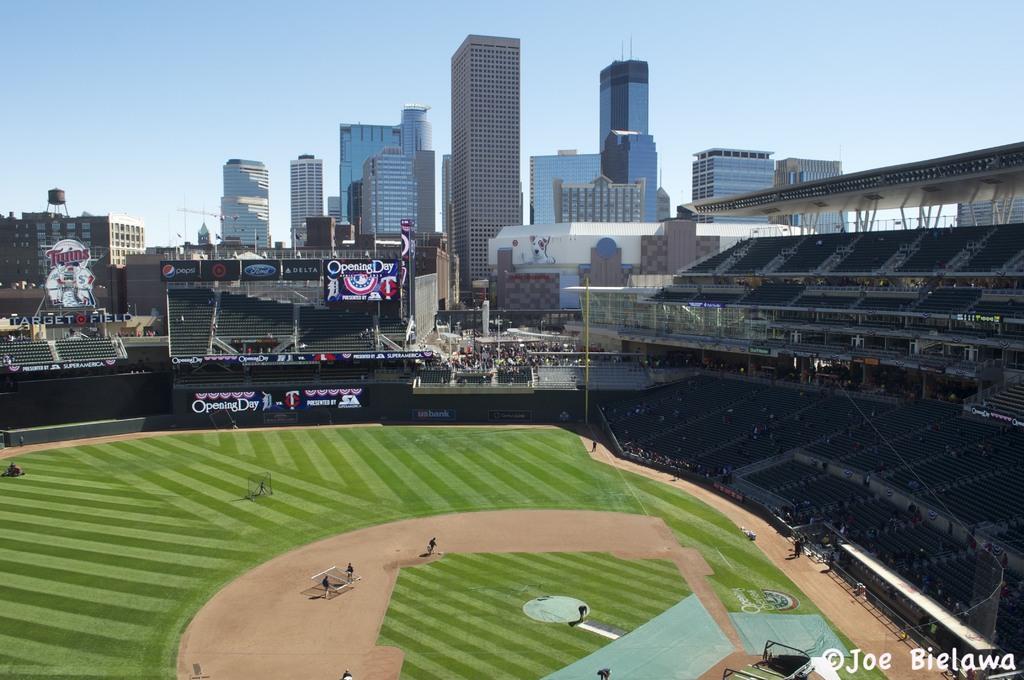Please provide a concise description of this image. In this picture we can see a stadium and in the stadium where are boards, chairs, poles and some people. Behind the stadium there are buildings and the sky. On the image there is a watermark. 